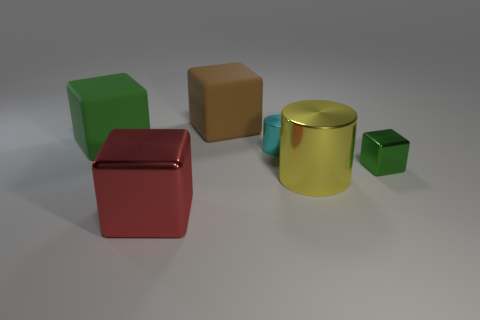How many other objects are there of the same material as the red object?
Your response must be concise. 3. What size is the yellow cylinder?
Ensure brevity in your answer.  Large. What number of other objects are the same color as the tiny cube?
Offer a very short reply. 1. The big thing that is behind the yellow metallic object and in front of the brown cube is what color?
Provide a succinct answer. Green. What number of big blue matte objects are there?
Provide a succinct answer. 0. Is the material of the big cylinder the same as the big red cube?
Provide a short and direct response. Yes. There is a green thing that is right of the shiny block that is to the left of the green object that is to the right of the large green matte block; what is its shape?
Provide a short and direct response. Cube. Does the green object that is to the left of the yellow metal cylinder have the same material as the block in front of the large metallic cylinder?
Give a very brief answer. No. What is the material of the brown cube?
Your answer should be very brief. Rubber. How many tiny cyan objects are the same shape as the large yellow object?
Provide a succinct answer. 1. 